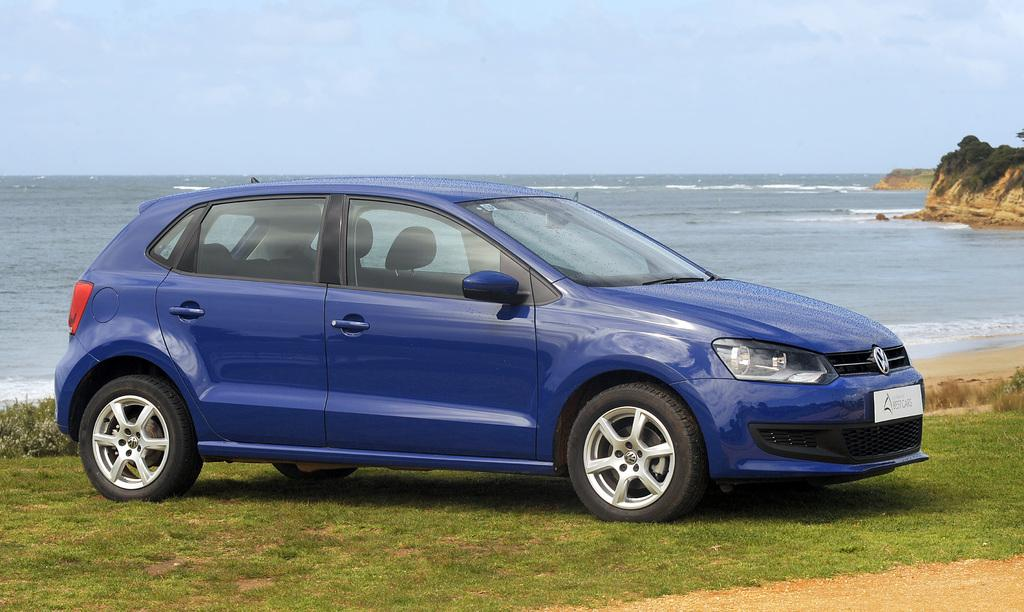What type of vegetation is present in the image? There is grass in the image. What type of vehicle can be seen in the image? There is a car in the image. What can be seen in the background of the image? There is water and clouds in the sky visible in the background of the image. What type of nose can be seen on the car in the image? There is no nose present on the car in the image. What type of destruction is visible in the image? There is no destruction visible in the image; it appears to be a peaceful scene with grass, a car, and a background with water and clouds. 